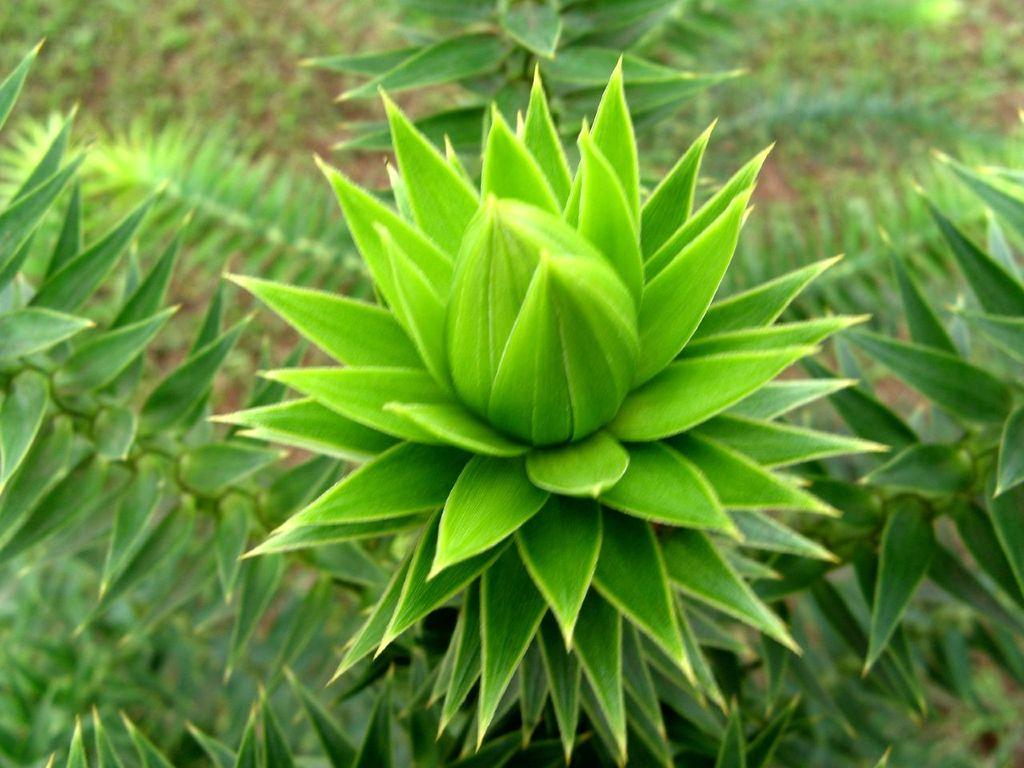What type of living organisms can be seen in the image? Plants can be seen in the image. What is the color of the plants in the image? The plants are green in color. What can be seen in the background of the image? There is land visible in the background of the image. What type of respect can be seen in the image? There is no indication of respect in the image, as it features plants and land. What current event is depicted in the image? There is no current event depicted in the image; it simply shows plants and land. 